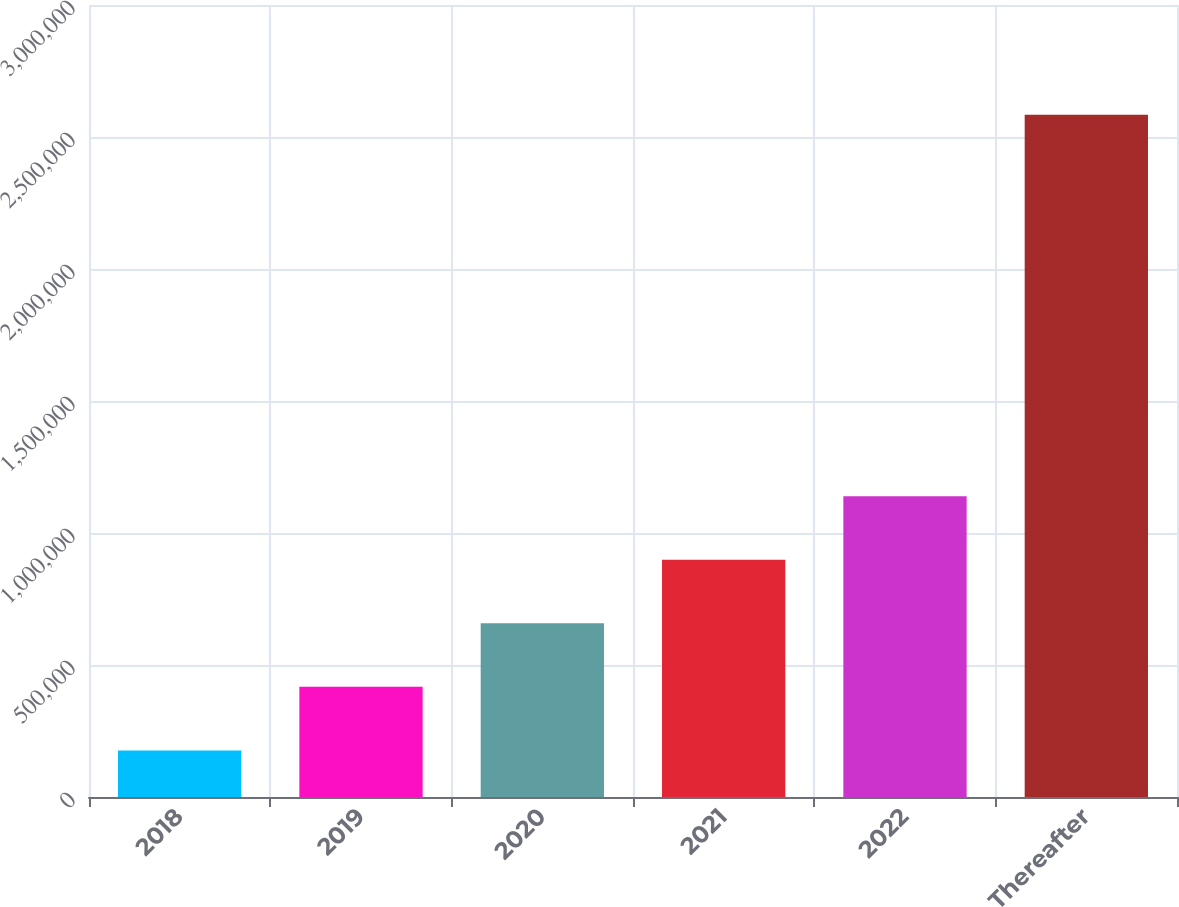Convert chart to OTSL. <chart><loc_0><loc_0><loc_500><loc_500><bar_chart><fcel>2018<fcel>2019<fcel>2020<fcel>2021<fcel>2022<fcel>Thereafter<nl><fcel>176432<fcel>417228<fcel>658023<fcel>898819<fcel>1.13961e+06<fcel>2.58439e+06<nl></chart> 